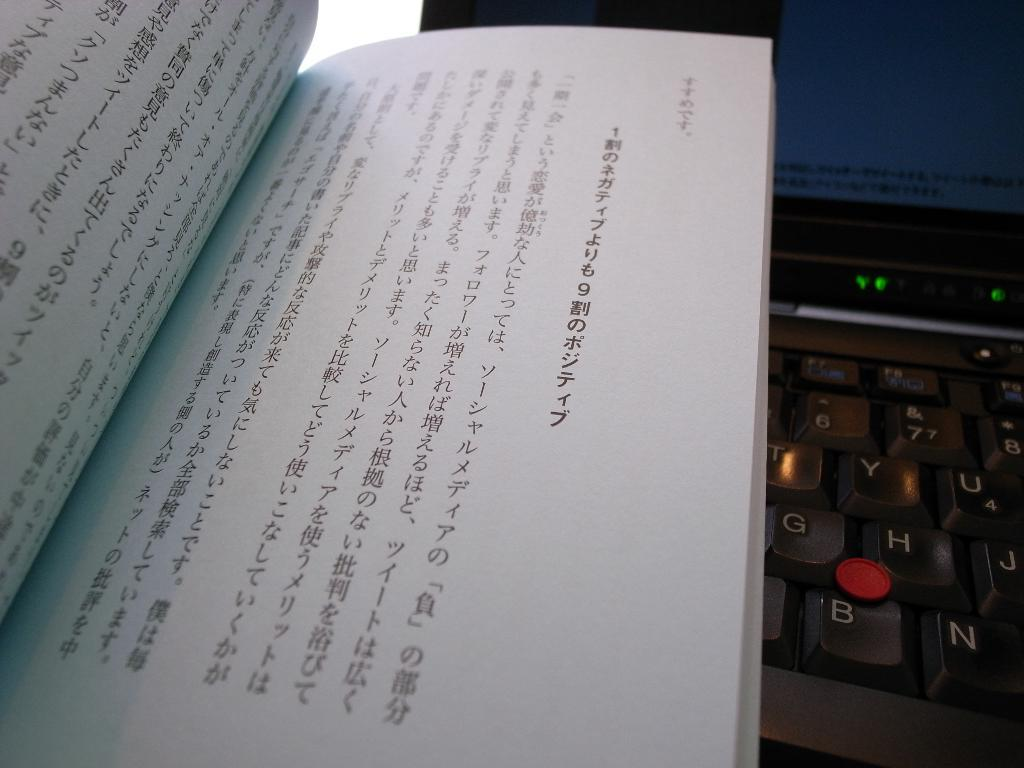Provide a one-sentence caption for the provided image. A japanese book is on top of a keyboard with a mouse nib above the B key. 